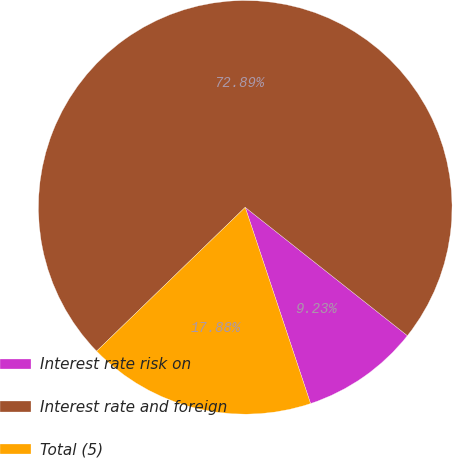Convert chart to OTSL. <chart><loc_0><loc_0><loc_500><loc_500><pie_chart><fcel>Interest rate risk on<fcel>Interest rate and foreign<fcel>Total (5)<nl><fcel>9.23%<fcel>72.89%<fcel>17.88%<nl></chart> 